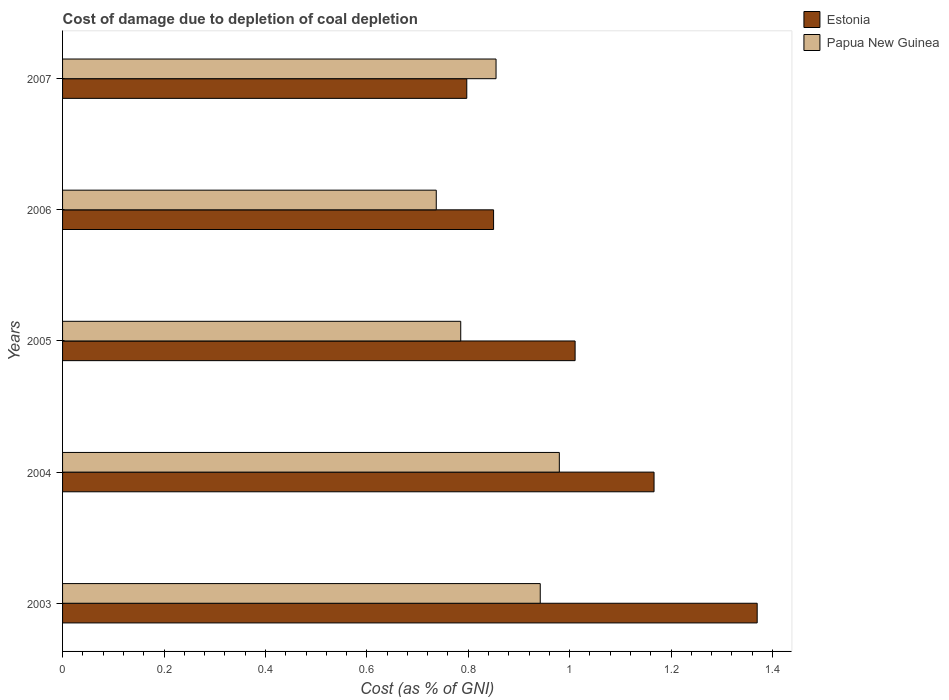How many groups of bars are there?
Provide a short and direct response. 5. How many bars are there on the 2nd tick from the bottom?
Your answer should be very brief. 2. What is the cost of damage caused due to coal depletion in Estonia in 2007?
Your response must be concise. 0.8. Across all years, what is the maximum cost of damage caused due to coal depletion in Estonia?
Your answer should be very brief. 1.37. Across all years, what is the minimum cost of damage caused due to coal depletion in Papua New Guinea?
Make the answer very short. 0.74. In which year was the cost of damage caused due to coal depletion in Estonia maximum?
Make the answer very short. 2003. What is the total cost of damage caused due to coal depletion in Estonia in the graph?
Provide a short and direct response. 5.19. What is the difference between the cost of damage caused due to coal depletion in Papua New Guinea in 2003 and that in 2005?
Keep it short and to the point. 0.16. What is the difference between the cost of damage caused due to coal depletion in Papua New Guinea in 2005 and the cost of damage caused due to coal depletion in Estonia in 2003?
Your answer should be very brief. -0.58. What is the average cost of damage caused due to coal depletion in Papua New Guinea per year?
Ensure brevity in your answer.  0.86. In the year 2006, what is the difference between the cost of damage caused due to coal depletion in Estonia and cost of damage caused due to coal depletion in Papua New Guinea?
Your answer should be very brief. 0.11. In how many years, is the cost of damage caused due to coal depletion in Estonia greater than 1.2400000000000002 %?
Your response must be concise. 1. What is the ratio of the cost of damage caused due to coal depletion in Papua New Guinea in 2005 to that in 2006?
Your response must be concise. 1.07. Is the difference between the cost of damage caused due to coal depletion in Estonia in 2003 and 2006 greater than the difference between the cost of damage caused due to coal depletion in Papua New Guinea in 2003 and 2006?
Your answer should be very brief. Yes. What is the difference between the highest and the second highest cost of damage caused due to coal depletion in Papua New Guinea?
Offer a very short reply. 0.04. What is the difference between the highest and the lowest cost of damage caused due to coal depletion in Papua New Guinea?
Your response must be concise. 0.24. In how many years, is the cost of damage caused due to coal depletion in Papua New Guinea greater than the average cost of damage caused due to coal depletion in Papua New Guinea taken over all years?
Provide a succinct answer. 2. What does the 1st bar from the top in 2004 represents?
Your answer should be very brief. Papua New Guinea. What does the 1st bar from the bottom in 2005 represents?
Your answer should be compact. Estonia. How many years are there in the graph?
Your answer should be compact. 5. What is the difference between two consecutive major ticks on the X-axis?
Make the answer very short. 0.2. Are the values on the major ticks of X-axis written in scientific E-notation?
Offer a terse response. No. Does the graph contain any zero values?
Ensure brevity in your answer.  No. Does the graph contain grids?
Ensure brevity in your answer.  No. How many legend labels are there?
Keep it short and to the point. 2. How are the legend labels stacked?
Make the answer very short. Vertical. What is the title of the graph?
Offer a terse response. Cost of damage due to depletion of coal depletion. What is the label or title of the X-axis?
Your response must be concise. Cost (as % of GNI). What is the label or title of the Y-axis?
Offer a terse response. Years. What is the Cost (as % of GNI) in Estonia in 2003?
Your response must be concise. 1.37. What is the Cost (as % of GNI) in Papua New Guinea in 2003?
Make the answer very short. 0.94. What is the Cost (as % of GNI) of Estonia in 2004?
Your answer should be compact. 1.17. What is the Cost (as % of GNI) of Papua New Guinea in 2004?
Ensure brevity in your answer.  0.98. What is the Cost (as % of GNI) of Estonia in 2005?
Provide a succinct answer. 1.01. What is the Cost (as % of GNI) in Papua New Guinea in 2005?
Offer a terse response. 0.79. What is the Cost (as % of GNI) of Estonia in 2006?
Provide a short and direct response. 0.85. What is the Cost (as % of GNI) in Papua New Guinea in 2006?
Offer a terse response. 0.74. What is the Cost (as % of GNI) of Estonia in 2007?
Ensure brevity in your answer.  0.8. What is the Cost (as % of GNI) in Papua New Guinea in 2007?
Provide a short and direct response. 0.85. Across all years, what is the maximum Cost (as % of GNI) in Estonia?
Give a very brief answer. 1.37. Across all years, what is the maximum Cost (as % of GNI) of Papua New Guinea?
Offer a very short reply. 0.98. Across all years, what is the minimum Cost (as % of GNI) of Estonia?
Your answer should be compact. 0.8. Across all years, what is the minimum Cost (as % of GNI) in Papua New Guinea?
Provide a succinct answer. 0.74. What is the total Cost (as % of GNI) of Estonia in the graph?
Make the answer very short. 5.19. What is the total Cost (as % of GNI) in Papua New Guinea in the graph?
Your response must be concise. 4.3. What is the difference between the Cost (as % of GNI) of Estonia in 2003 and that in 2004?
Your answer should be compact. 0.2. What is the difference between the Cost (as % of GNI) of Papua New Guinea in 2003 and that in 2004?
Provide a succinct answer. -0.04. What is the difference between the Cost (as % of GNI) of Estonia in 2003 and that in 2005?
Provide a short and direct response. 0.36. What is the difference between the Cost (as % of GNI) of Papua New Guinea in 2003 and that in 2005?
Your answer should be very brief. 0.16. What is the difference between the Cost (as % of GNI) of Estonia in 2003 and that in 2006?
Offer a terse response. 0.52. What is the difference between the Cost (as % of GNI) in Papua New Guinea in 2003 and that in 2006?
Keep it short and to the point. 0.2. What is the difference between the Cost (as % of GNI) of Estonia in 2003 and that in 2007?
Keep it short and to the point. 0.57. What is the difference between the Cost (as % of GNI) in Papua New Guinea in 2003 and that in 2007?
Give a very brief answer. 0.09. What is the difference between the Cost (as % of GNI) in Estonia in 2004 and that in 2005?
Keep it short and to the point. 0.16. What is the difference between the Cost (as % of GNI) in Papua New Guinea in 2004 and that in 2005?
Give a very brief answer. 0.19. What is the difference between the Cost (as % of GNI) of Estonia in 2004 and that in 2006?
Offer a terse response. 0.32. What is the difference between the Cost (as % of GNI) in Papua New Guinea in 2004 and that in 2006?
Your response must be concise. 0.24. What is the difference between the Cost (as % of GNI) in Estonia in 2004 and that in 2007?
Ensure brevity in your answer.  0.37. What is the difference between the Cost (as % of GNI) in Papua New Guinea in 2004 and that in 2007?
Ensure brevity in your answer.  0.12. What is the difference between the Cost (as % of GNI) in Estonia in 2005 and that in 2006?
Ensure brevity in your answer.  0.16. What is the difference between the Cost (as % of GNI) in Papua New Guinea in 2005 and that in 2006?
Offer a very short reply. 0.05. What is the difference between the Cost (as % of GNI) in Estonia in 2005 and that in 2007?
Provide a succinct answer. 0.21. What is the difference between the Cost (as % of GNI) of Papua New Guinea in 2005 and that in 2007?
Make the answer very short. -0.07. What is the difference between the Cost (as % of GNI) in Estonia in 2006 and that in 2007?
Your answer should be compact. 0.05. What is the difference between the Cost (as % of GNI) in Papua New Guinea in 2006 and that in 2007?
Provide a short and direct response. -0.12. What is the difference between the Cost (as % of GNI) of Estonia in 2003 and the Cost (as % of GNI) of Papua New Guinea in 2004?
Give a very brief answer. 0.39. What is the difference between the Cost (as % of GNI) in Estonia in 2003 and the Cost (as % of GNI) in Papua New Guinea in 2005?
Offer a very short reply. 0.58. What is the difference between the Cost (as % of GNI) of Estonia in 2003 and the Cost (as % of GNI) of Papua New Guinea in 2006?
Keep it short and to the point. 0.63. What is the difference between the Cost (as % of GNI) in Estonia in 2003 and the Cost (as % of GNI) in Papua New Guinea in 2007?
Keep it short and to the point. 0.51. What is the difference between the Cost (as % of GNI) of Estonia in 2004 and the Cost (as % of GNI) of Papua New Guinea in 2005?
Offer a terse response. 0.38. What is the difference between the Cost (as % of GNI) of Estonia in 2004 and the Cost (as % of GNI) of Papua New Guinea in 2006?
Ensure brevity in your answer.  0.43. What is the difference between the Cost (as % of GNI) in Estonia in 2004 and the Cost (as % of GNI) in Papua New Guinea in 2007?
Your answer should be very brief. 0.31. What is the difference between the Cost (as % of GNI) in Estonia in 2005 and the Cost (as % of GNI) in Papua New Guinea in 2006?
Your response must be concise. 0.27. What is the difference between the Cost (as % of GNI) in Estonia in 2005 and the Cost (as % of GNI) in Papua New Guinea in 2007?
Give a very brief answer. 0.16. What is the difference between the Cost (as % of GNI) of Estonia in 2006 and the Cost (as % of GNI) of Papua New Guinea in 2007?
Your answer should be compact. -0. What is the average Cost (as % of GNI) in Estonia per year?
Your answer should be very brief. 1.04. What is the average Cost (as % of GNI) of Papua New Guinea per year?
Ensure brevity in your answer.  0.86. In the year 2003, what is the difference between the Cost (as % of GNI) in Estonia and Cost (as % of GNI) in Papua New Guinea?
Your response must be concise. 0.43. In the year 2004, what is the difference between the Cost (as % of GNI) of Estonia and Cost (as % of GNI) of Papua New Guinea?
Provide a short and direct response. 0.19. In the year 2005, what is the difference between the Cost (as % of GNI) of Estonia and Cost (as % of GNI) of Papua New Guinea?
Ensure brevity in your answer.  0.23. In the year 2006, what is the difference between the Cost (as % of GNI) of Estonia and Cost (as % of GNI) of Papua New Guinea?
Provide a short and direct response. 0.11. In the year 2007, what is the difference between the Cost (as % of GNI) in Estonia and Cost (as % of GNI) in Papua New Guinea?
Provide a succinct answer. -0.06. What is the ratio of the Cost (as % of GNI) in Estonia in 2003 to that in 2004?
Give a very brief answer. 1.17. What is the ratio of the Cost (as % of GNI) in Papua New Guinea in 2003 to that in 2004?
Your response must be concise. 0.96. What is the ratio of the Cost (as % of GNI) of Estonia in 2003 to that in 2005?
Offer a very short reply. 1.36. What is the ratio of the Cost (as % of GNI) of Papua New Guinea in 2003 to that in 2005?
Your response must be concise. 1.2. What is the ratio of the Cost (as % of GNI) of Estonia in 2003 to that in 2006?
Give a very brief answer. 1.61. What is the ratio of the Cost (as % of GNI) of Papua New Guinea in 2003 to that in 2006?
Provide a succinct answer. 1.28. What is the ratio of the Cost (as % of GNI) in Estonia in 2003 to that in 2007?
Provide a short and direct response. 1.72. What is the ratio of the Cost (as % of GNI) in Papua New Guinea in 2003 to that in 2007?
Your answer should be compact. 1.1. What is the ratio of the Cost (as % of GNI) in Estonia in 2004 to that in 2005?
Your response must be concise. 1.15. What is the ratio of the Cost (as % of GNI) of Papua New Guinea in 2004 to that in 2005?
Your response must be concise. 1.25. What is the ratio of the Cost (as % of GNI) of Estonia in 2004 to that in 2006?
Offer a terse response. 1.37. What is the ratio of the Cost (as % of GNI) of Papua New Guinea in 2004 to that in 2006?
Provide a succinct answer. 1.33. What is the ratio of the Cost (as % of GNI) of Estonia in 2004 to that in 2007?
Your answer should be compact. 1.46. What is the ratio of the Cost (as % of GNI) in Papua New Guinea in 2004 to that in 2007?
Provide a short and direct response. 1.15. What is the ratio of the Cost (as % of GNI) of Estonia in 2005 to that in 2006?
Offer a terse response. 1.19. What is the ratio of the Cost (as % of GNI) in Papua New Guinea in 2005 to that in 2006?
Keep it short and to the point. 1.07. What is the ratio of the Cost (as % of GNI) of Estonia in 2005 to that in 2007?
Your response must be concise. 1.27. What is the ratio of the Cost (as % of GNI) of Papua New Guinea in 2005 to that in 2007?
Provide a succinct answer. 0.92. What is the ratio of the Cost (as % of GNI) of Estonia in 2006 to that in 2007?
Your response must be concise. 1.07. What is the ratio of the Cost (as % of GNI) in Papua New Guinea in 2006 to that in 2007?
Your answer should be very brief. 0.86. What is the difference between the highest and the second highest Cost (as % of GNI) of Estonia?
Your response must be concise. 0.2. What is the difference between the highest and the second highest Cost (as % of GNI) in Papua New Guinea?
Provide a short and direct response. 0.04. What is the difference between the highest and the lowest Cost (as % of GNI) in Estonia?
Make the answer very short. 0.57. What is the difference between the highest and the lowest Cost (as % of GNI) of Papua New Guinea?
Ensure brevity in your answer.  0.24. 